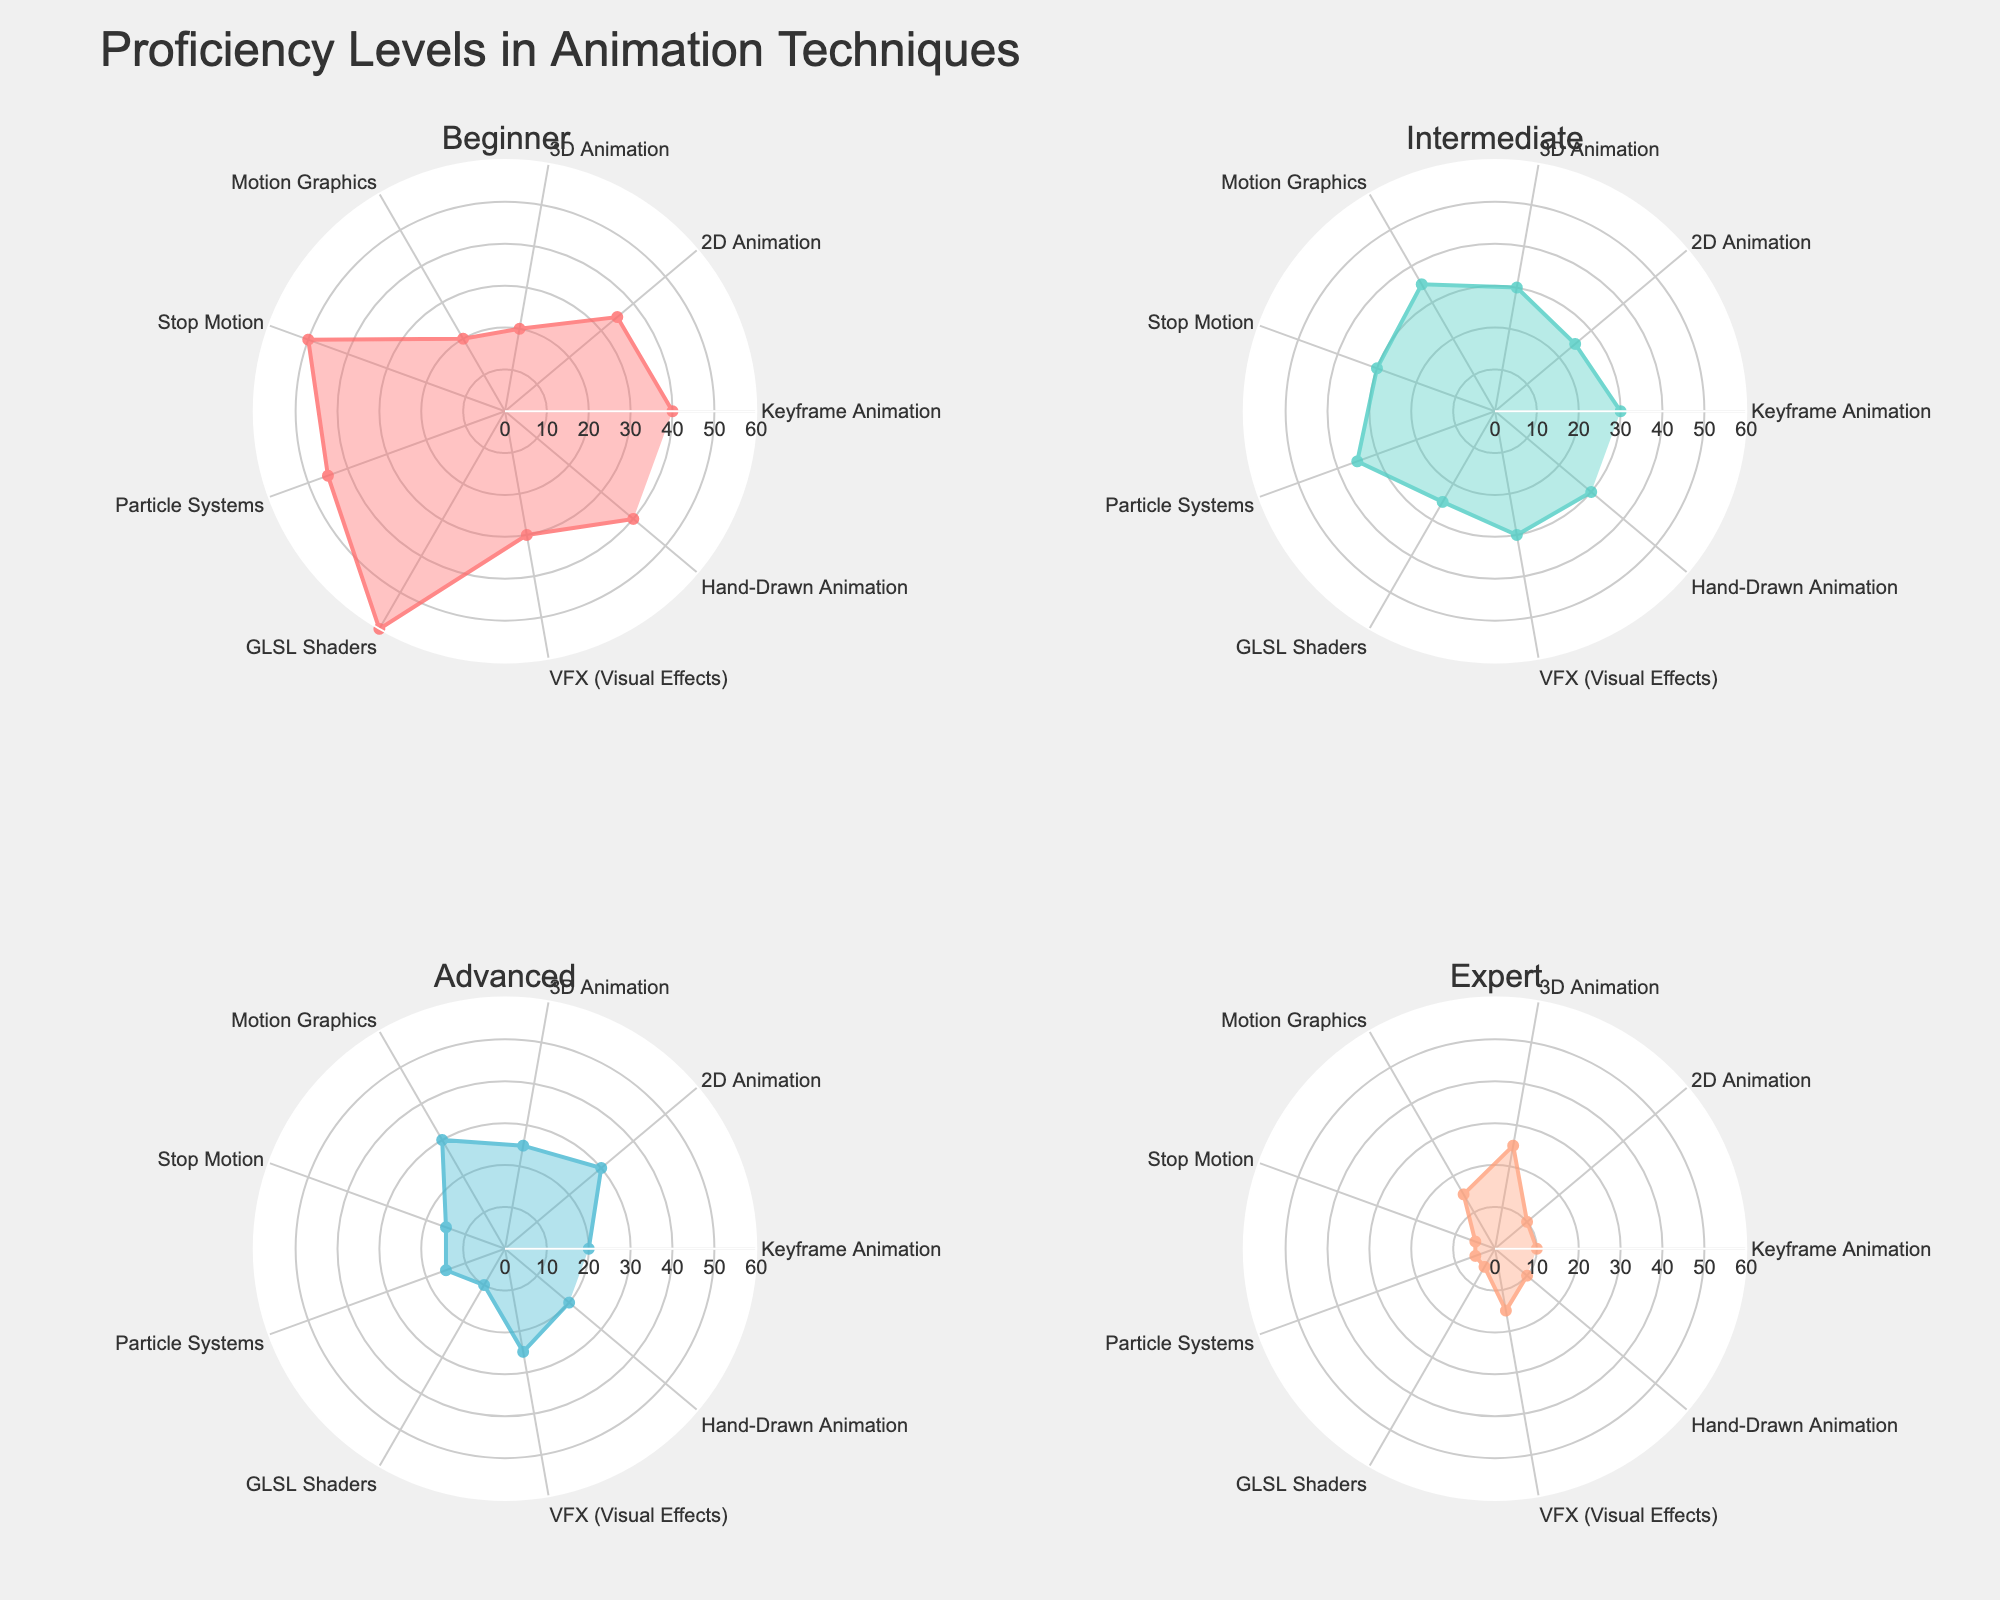What is the title of the figure? The title of the figure is located at the top and provides an overview of the chart's content. So, it indicates the main topic being visualized.
Answer: Proficiency Levels in Animation Techniques Which technique has the highest number of experts? The experts' proficiency subplot (usually indicated around the bottom left of the radar charts) will have the technique with the longest radial distance representing the highest number.
Answer: 3D Animation Compare the proficiency levels of Stop Motion and Particle Systems in the Intermediate category. Which one has more? By looking at the Intermediate subplot, compare the radial lengths for Stop Motion and Particle Systems. The longer the radius, the higher the proficiency levels.
Answer: Particle Systems What is the range of values on the radial axis? The radial axis range is determined by the scale set on the polar axes. Look at the outermost and innermost markings.
Answer: 0 to 60 How many techniques have fewer than 10 experts? Check the subplot for experts and count the number of techniques where the radial distance is less than the corresponding tick mark for value 10.
Answer: 6 Which animation technique shows the highest beginner proficiency level? In the Beginner subplot, find the technique with the longest radial distance. The further the point from the center, the higher the proficiency level.
Answer: GLSL Shaders What is the sum of the Advanced proficiency levels for Keyframe Animation and Motion Graphics? Locate the Advanced proficiency subplot. Measure the radial distances for Keyframe Animation and Motion Graphics, then add these values together.
Answer: 20 + 30 = 50 In which two categories does Hand-Drawn Animation have the same proficiency levels? Check the radial distances for Hand-Drawn Animation across all subplots and find the matching values.
Answer: Beginner and Advanced Which proficiency category has the most even distribution across all techniques? Scan through each subplot and observe the variance in radial distances for all techniques. The category with the most similar lengths shows the most even distribution.
Answer: Intermediate What is the difference between the highest and lowest numbers of experts across all techniques? Identify the highest and lowest radial distances in the Expert subplot, then subtract the smallest value from the largest.
Answer: 25 - 5 = 20 